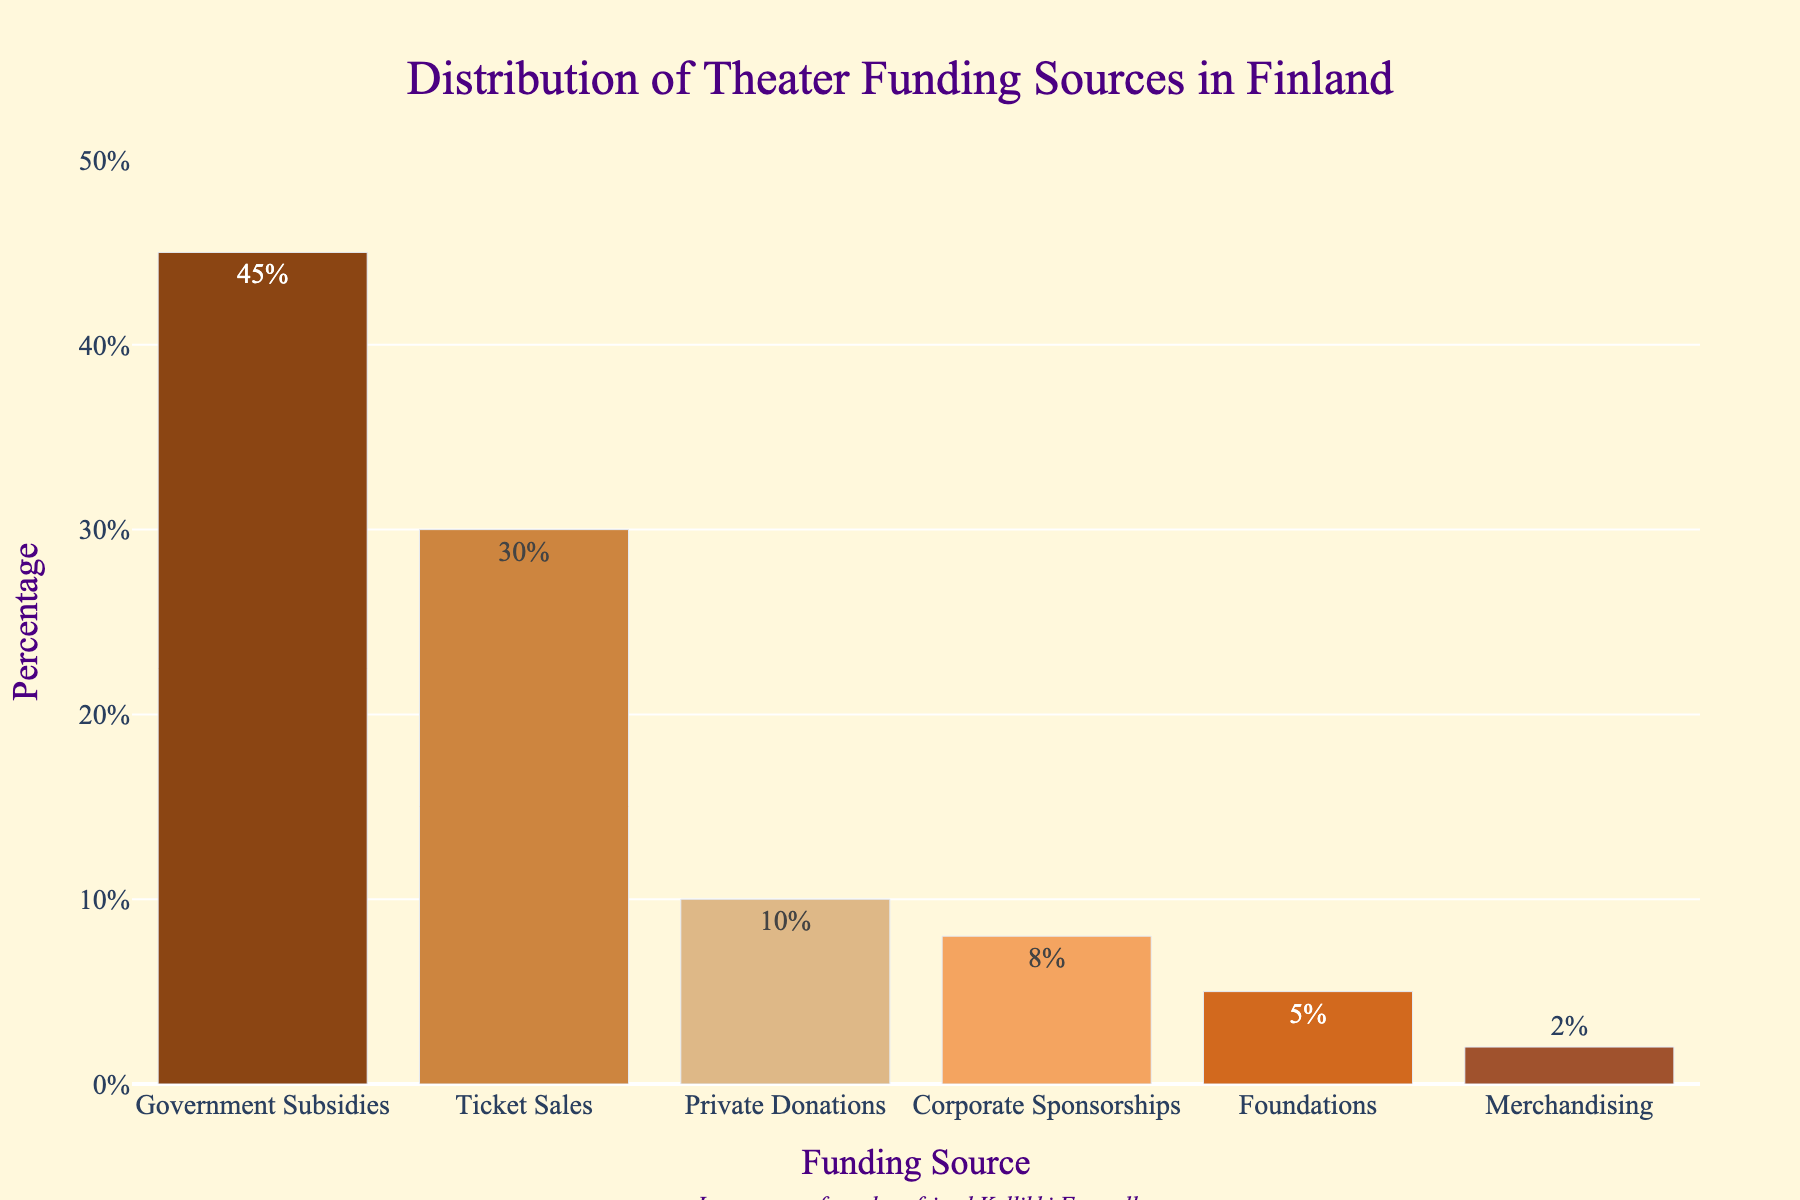What's the largest source of theater funding in Finland according to the chart? The bar for "Government Subsidies" is the tallest, indicating it has the highest percentage among the funding sources.
Answer: Government Subsidies What's the combined percentage of funding from Private Donations and Corporate Sponsorships? Private Donations contribute 10% and Corporate Sponsorships contribute 8%. Adding these percentages gives 10% + 8% = 18%.
Answer: 18% Which funding source contributes less, Foundations or Merchandising? The bar representing Merchandising is shorter than the bar for Foundations, indicating it contributes a smaller percentage.
Answer: Merchandising How much more does Ticket Sales contribute to theater funding compared to Corporate Sponsorships? Ticket Sales contribute 30% and Corporate Sponsorships contribute 8%. The difference is 30% - 8% = 22%.
Answer: 22% Are Private Donations and Foundations combined greater than Government Subsidies? Private Donations contribute 10% and Foundations contribute 5%, so their combined contribution is 10% + 5% = 15%. Government Subsidies contribute 45%, which is greater than 15%.
Answer: No What is the difference in percentage between the highest and lowest funding sources? The highest funding source is Government Subsidies at 45%, and the lowest is Merchandising at 2%. The difference is 45% - 2% = 43%.
Answer: 43% Which funding sources have percentages that are less than half of Ticket Sales? Ticket Sales is 30%, so half of that is 15%. The sources contributing less than 15% are Private Donations (10%), Corporate Sponsorships (8%), Foundations (5%), and Merchandising (2%).
Answer: Private Donations, Corporate Sponsorships, Foundations, Merchandising What's the percentage contribution of all sources other than Government Subsidies? Excluding Government Subsidies at 45%, the other sources are Ticket Sales (30%), Private Donations (10%), Corporate Sponsorships (8%), Foundations (5%), and Merchandising (2%). Adding these gives 30% + 10% + 8% + 5% + 2% = 55%.
Answer: 55% If the percentage of Corporate Sponsorships were doubled, how would it compare to Ticket Sales? Currently, Corporate Sponsorships contribute 8%. Doubling this percentage gives 8% * 2 = 16%. Ticket Sales contribute 30%, which is higher than 16%.
Answer: Ticket Sales would still be higher In memory of whom is the figure dedicated? The annotation at the bottom of the figure mentions it is dedicated "In memory of my dear friend Kyllikki Forssell".
Answer: Kyllikki Forssell 